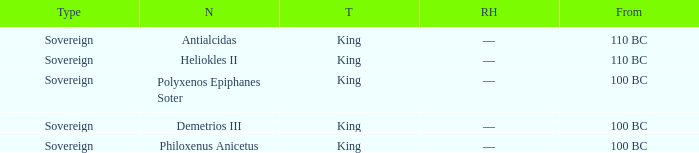Which royal house corresponds to Polyxenos Epiphanes Soter? —. 